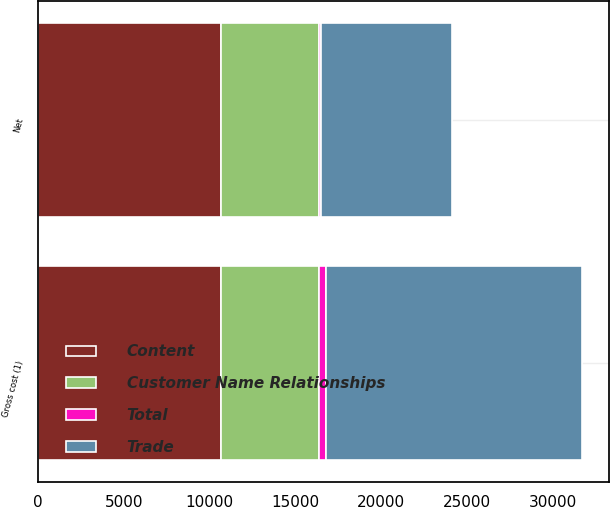Convert chart. <chart><loc_0><loc_0><loc_500><loc_500><stacked_bar_chart><ecel><fcel>Gross cost (1)<fcel>Net<nl><fcel>Content<fcel>10634<fcel>10634<nl><fcel>Customer Name Relationships<fcel>5758<fcel>5758<nl><fcel>Trade<fcel>14910<fcel>7595<nl><fcel>Total<fcel>416<fcel>126<nl></chart> 